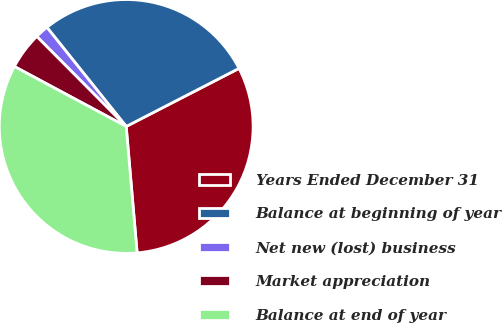<chart> <loc_0><loc_0><loc_500><loc_500><pie_chart><fcel>Years Ended December 31<fcel>Balance at beginning of year<fcel>Net new (lost) business<fcel>Market appreciation<fcel>Balance at end of year<nl><fcel>31.19%<fcel>28.17%<fcel>1.71%<fcel>4.72%<fcel>34.2%<nl></chart> 